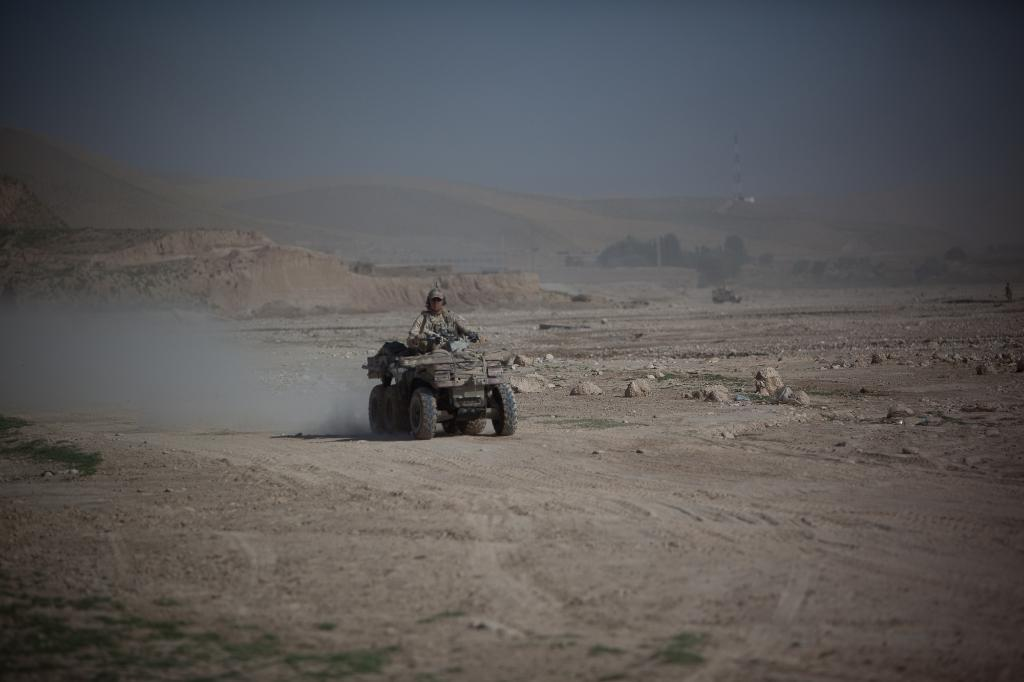What is the person in the image doing? The person in the image is sitting on a motor vehicle. What type of landscape can be seen in the image? Plains are visible in the image. What other natural elements are present in the image? There are trees in the image. What man-made structure can be seen in the image? There is an electric tower in the image. What is visible in the background of the image? The sky is visible in the image. What type of acoustics can be heard in the image? There is no information about sounds or acoustics in the image, so it cannot be determined from the image. 